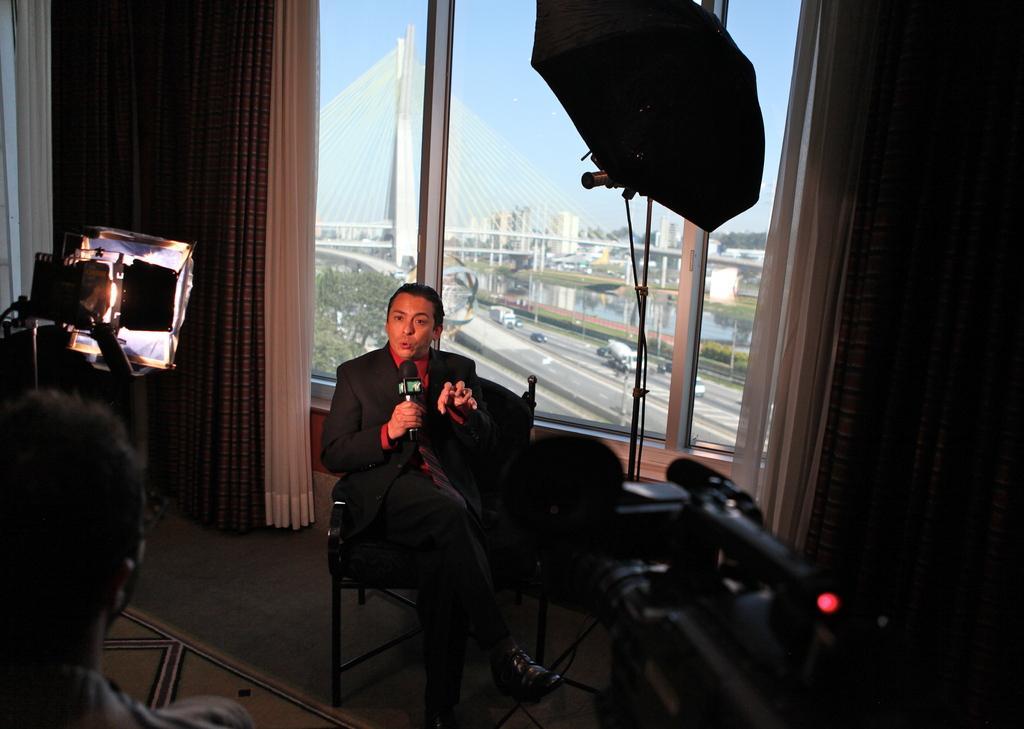How would you summarize this image in a sentence or two? In this image there is a person sitting on the chair and holding a mike, and there is a camera , another person, umbrella with a stand , there is a camera flashlight, carpet, there are curtains, window, and in the background there are vehicles on the road, there are buildings, trees, bridge and sky. 